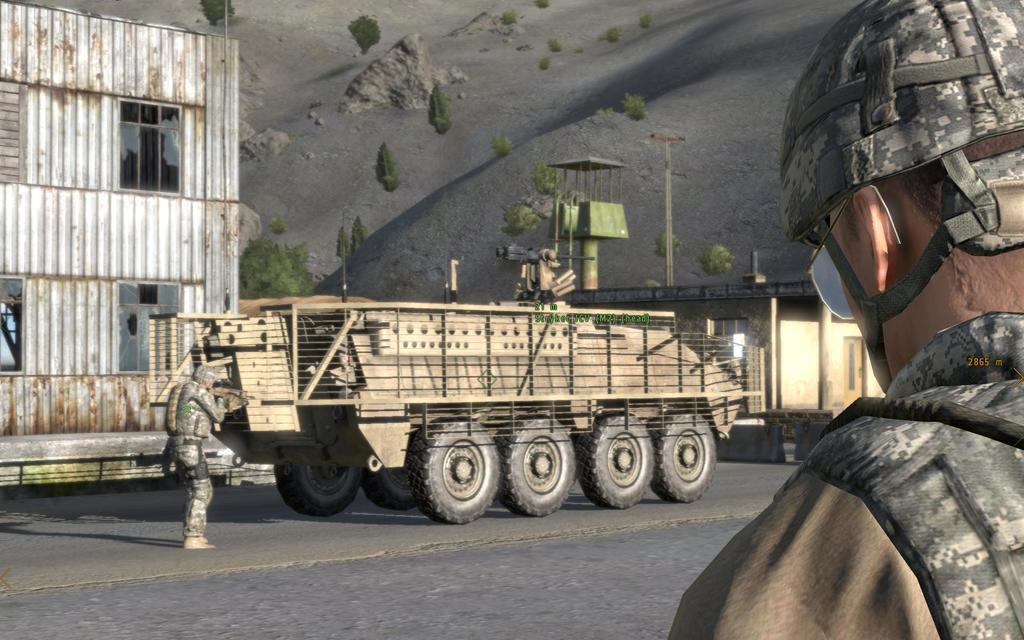What type of image is being described? The image appears to be animated. Can you describe the man in the image? There is a man on the right side of the image. What structure is located on the left side of the image? There is a cabin on the left side of the image. What is in the middle of the image? There is a vehicle in the middle of the image. What is at the bottom of the image? There is a road at the bottom of the image. Can you tell me how many giraffes are present in the image? There are no giraffes present in the image; the subjects include a man, a cabin, a vehicle, and a road. What type of pen is being used by the man in the image? There is no pen visible in the image; the man is not holding or using any writing instrument. 